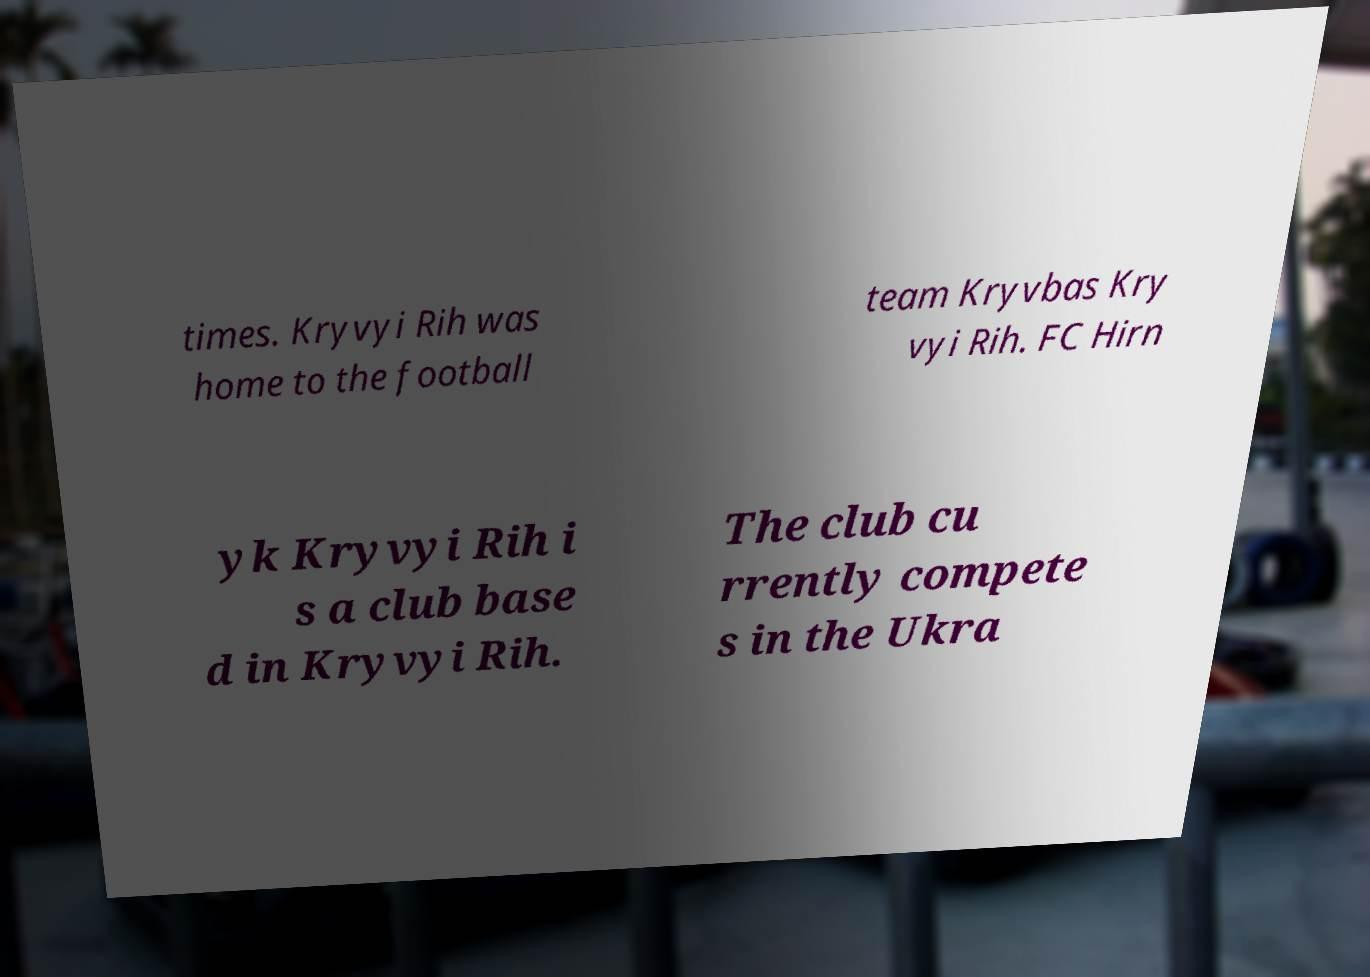Please identify and transcribe the text found in this image. times. Kryvyi Rih was home to the football team Kryvbas Kry vyi Rih. FC Hirn yk Kryvyi Rih i s a club base d in Kryvyi Rih. The club cu rrently compete s in the Ukra 